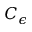Convert formula to latex. <formula><loc_0><loc_0><loc_500><loc_500>C _ { \epsilon }</formula> 